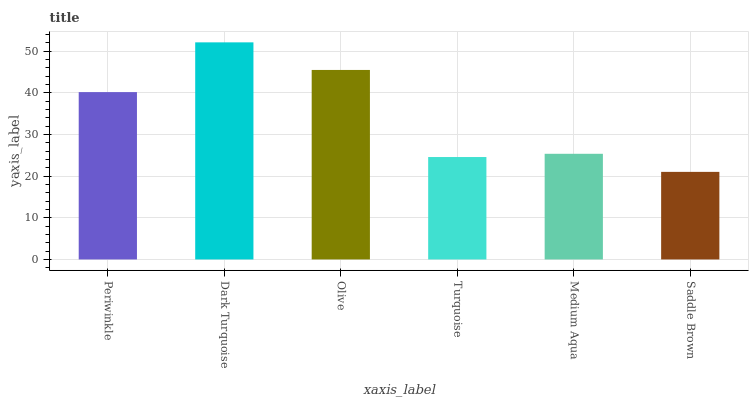Is Saddle Brown the minimum?
Answer yes or no. Yes. Is Dark Turquoise the maximum?
Answer yes or no. Yes. Is Olive the minimum?
Answer yes or no. No. Is Olive the maximum?
Answer yes or no. No. Is Dark Turquoise greater than Olive?
Answer yes or no. Yes. Is Olive less than Dark Turquoise?
Answer yes or no. Yes. Is Olive greater than Dark Turquoise?
Answer yes or no. No. Is Dark Turquoise less than Olive?
Answer yes or no. No. Is Periwinkle the high median?
Answer yes or no. Yes. Is Medium Aqua the low median?
Answer yes or no. Yes. Is Dark Turquoise the high median?
Answer yes or no. No. Is Saddle Brown the low median?
Answer yes or no. No. 